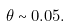Convert formula to latex. <formula><loc_0><loc_0><loc_500><loc_500>\theta \sim 0 . 0 5 .</formula> 